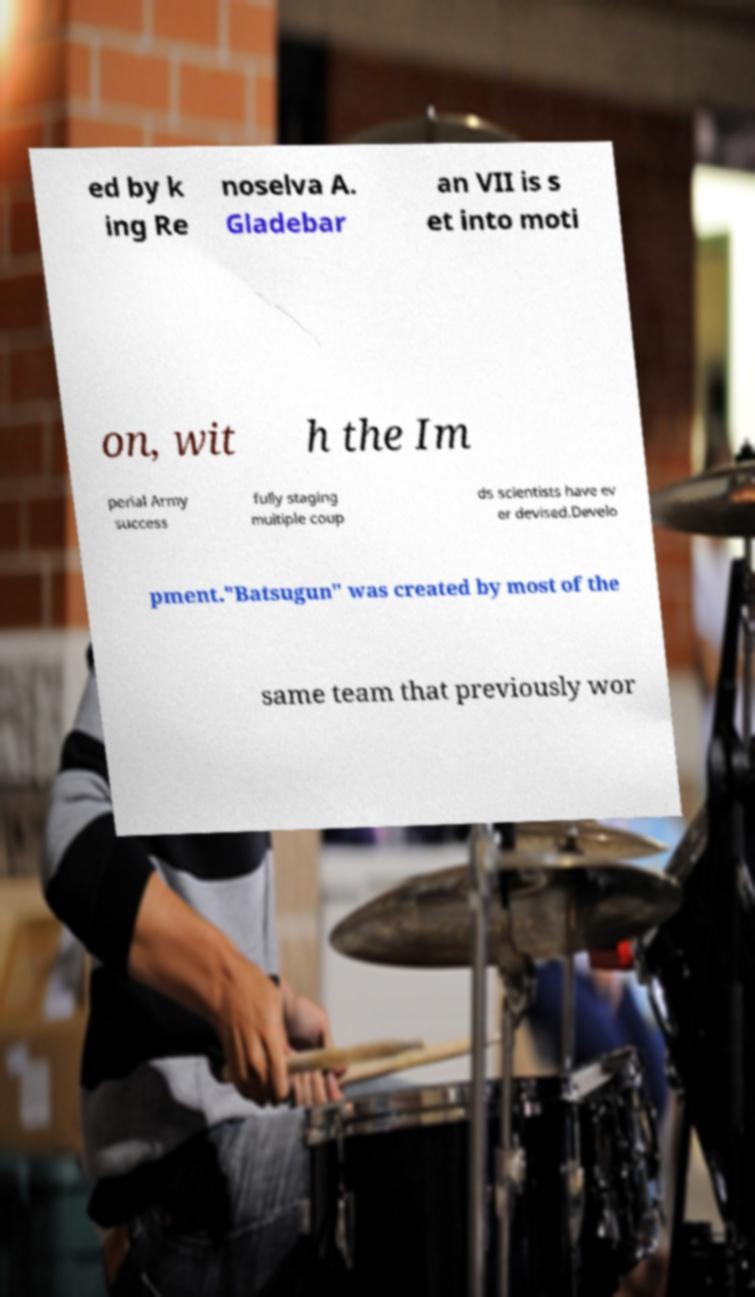Could you assist in decoding the text presented in this image and type it out clearly? ed by k ing Re noselva A. Gladebar an VII is s et into moti on, wit h the Im perial Army success fully staging multiple coup ds scientists have ev er devised.Develo pment."Batsugun" was created by most of the same team that previously wor 